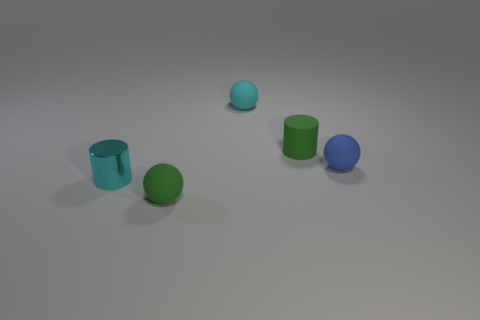Add 3 big brown metallic things. How many objects exist? 8 Subtract all balls. How many objects are left? 2 Add 2 tiny blue spheres. How many tiny blue spheres are left? 3 Add 4 tiny green matte spheres. How many tiny green matte spheres exist? 5 Subtract 0 purple cylinders. How many objects are left? 5 Subtract all small purple metal blocks. Subtract all tiny balls. How many objects are left? 2 